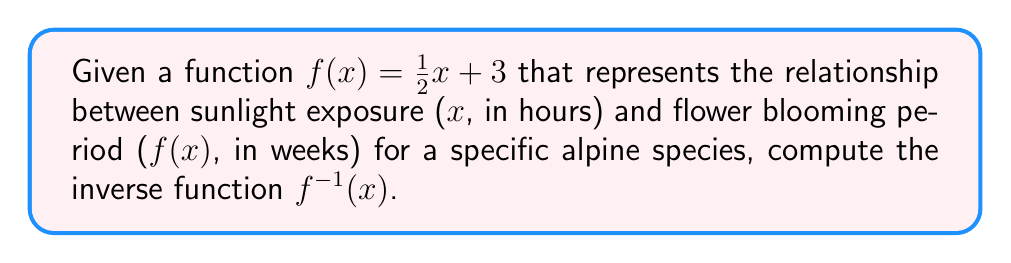Can you answer this question? To find the inverse function, we follow these steps:

1) Replace $f(x)$ with $y$:
   $y = \frac{1}{2}x + 3$

2) Swap $x$ and $y$:
   $x = \frac{1}{2}y + 3$

3) Solve for $y$:
   $x - 3 = \frac{1}{2}y$
   $2(x - 3) = y$
   $2x - 6 = y$

4) Replace $y$ with $f^{-1}(x)$:
   $f^{-1}(x) = 2x - 6$

This inverse function allows us to determine the sunlight exposure (in hours) needed for a given blooming period (in weeks) for the alpine species.
Answer: $f^{-1}(x) = 2x - 6$ 